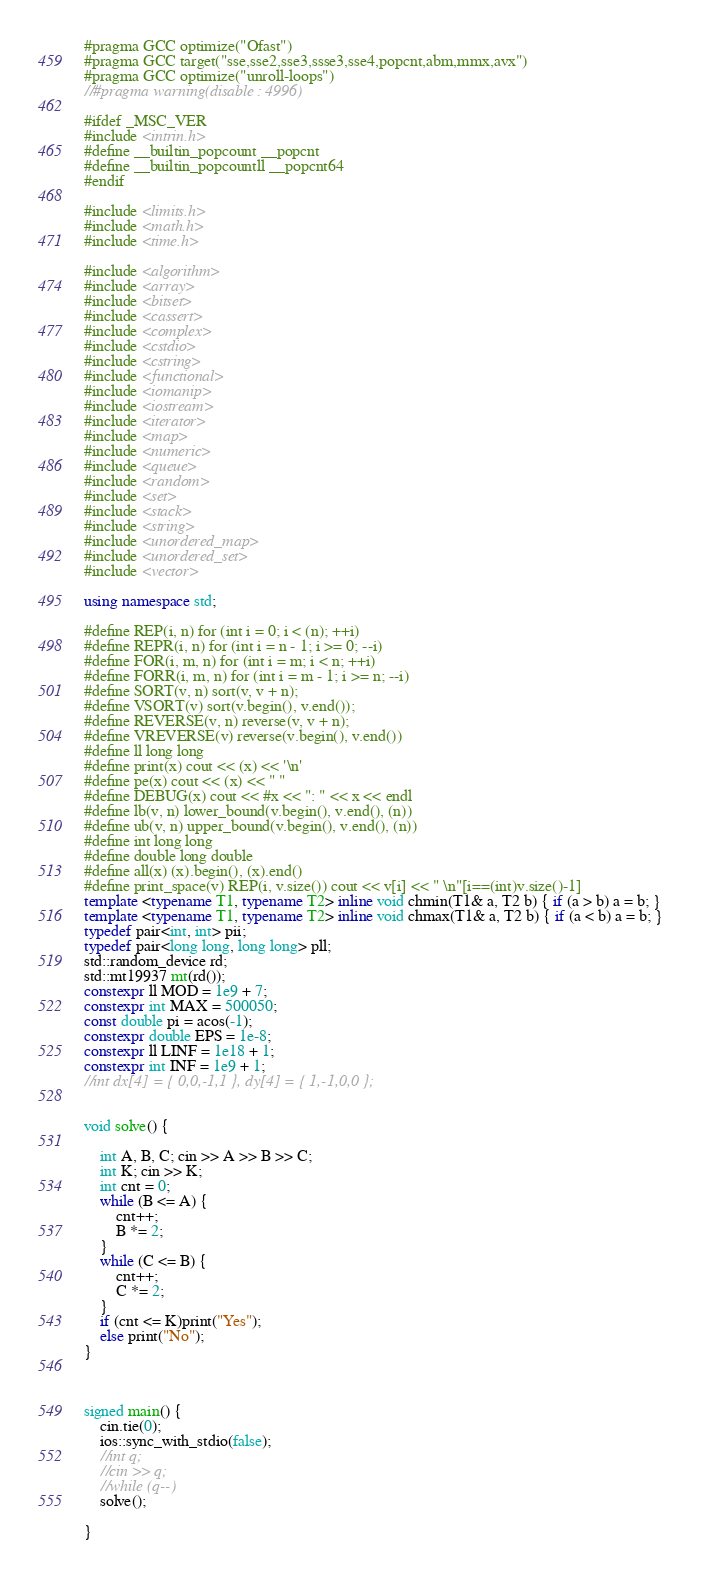<code> <loc_0><loc_0><loc_500><loc_500><_C++_>#pragma GCC optimize("Ofast")
#pragma GCC target("sse,sse2,sse3,ssse3,sse4,popcnt,abm,mmx,avx")
#pragma GCC optimize("unroll-loops")
//#pragma warning(disable : 4996)

#ifdef _MSC_VER
#include <intrin.h>
#define __builtin_popcount __popcnt
#define __builtin_popcountll __popcnt64
#endif

#include <limits.h>
#include <math.h>
#include <time.h>

#include <algorithm>
#include <array>
#include <bitset>
#include <cassert>
#include <complex>
#include <cstdio>
#include <cstring>
#include <functional>
#include <iomanip>
#include <iostream>
#include <iterator>
#include <map>
#include <numeric>
#include <queue>
#include <random>
#include <set>
#include <stack>
#include <string>
#include <unordered_map>
#include <unordered_set>
#include <vector>

using namespace std;

#define REP(i, n) for (int i = 0; i < (n); ++i)
#define REPR(i, n) for (int i = n - 1; i >= 0; --i)
#define FOR(i, m, n) for (int i = m; i < n; ++i)
#define FORR(i, m, n) for (int i = m - 1; i >= n; --i)
#define SORT(v, n) sort(v, v + n);
#define VSORT(v) sort(v.begin(), v.end());
#define REVERSE(v, n) reverse(v, v + n);
#define VREVERSE(v) reverse(v.begin(), v.end())
#define ll long long
#define print(x) cout << (x) << '\n'
#define pe(x) cout << (x) << " "
#define DEBUG(x) cout << #x << ": " << x << endl
#define lb(v, n) lower_bound(v.begin(), v.end(), (n))
#define ub(v, n) upper_bound(v.begin(), v.end(), (n))
#define int long long
#define double long double
#define all(x) (x).begin(), (x).end()
#define print_space(v) REP(i, v.size()) cout << v[i] << " \n"[i==(int)v.size()-1]
template <typename T1, typename T2> inline void chmin(T1& a, T2 b) { if (a > b) a = b; }
template <typename T1, typename T2> inline void chmax(T1& a, T2 b) { if (a < b) a = b; }
typedef pair<int, int> pii;
typedef pair<long long, long long> pll;
std::random_device rd;
std::mt19937 mt(rd());
constexpr ll MOD = 1e9 + 7;
constexpr int MAX = 500050;
const double pi = acos(-1);
constexpr double EPS = 1e-8;
constexpr ll LINF = 1e18 + 1;
constexpr int INF = 1e9 + 1;
//int dx[4] = { 0,0,-1,1 }, dy[4] = { 1,-1,0,0 };


void solve() {

	int A, B, C; cin >> A >> B >> C;
	int K; cin >> K;
	int cnt = 0;
	while (B <= A) {
		cnt++;
		B *= 2;
	}
	while (C <= B) {
		cnt++;
		C *= 2;
	}
	if (cnt <= K)print("Yes");
	else print("No");
}



signed main() {
	cin.tie(0);
	ios::sync_with_stdio(false);
	//int q;
	//cin >> q;
	//while (q--)
	solve();

}
</code> 